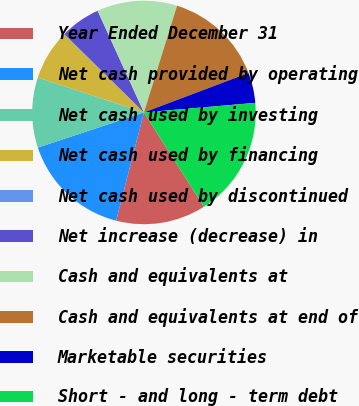<chart> <loc_0><loc_0><loc_500><loc_500><pie_chart><fcel>Year Ended December 31<fcel>Net cash provided by operating<fcel>Net cash used by investing<fcel>Net cash used by financing<fcel>Net cash used by discontinued<fcel>Net increase (decrease) in<fcel>Cash and equivalents at<fcel>Cash and equivalents at end of<fcel>Marketable securities<fcel>Short - and long - term debt<nl><fcel>13.03%<fcel>15.91%<fcel>10.14%<fcel>7.26%<fcel>0.06%<fcel>5.82%<fcel>11.59%<fcel>14.47%<fcel>4.38%<fcel>17.35%<nl></chart> 